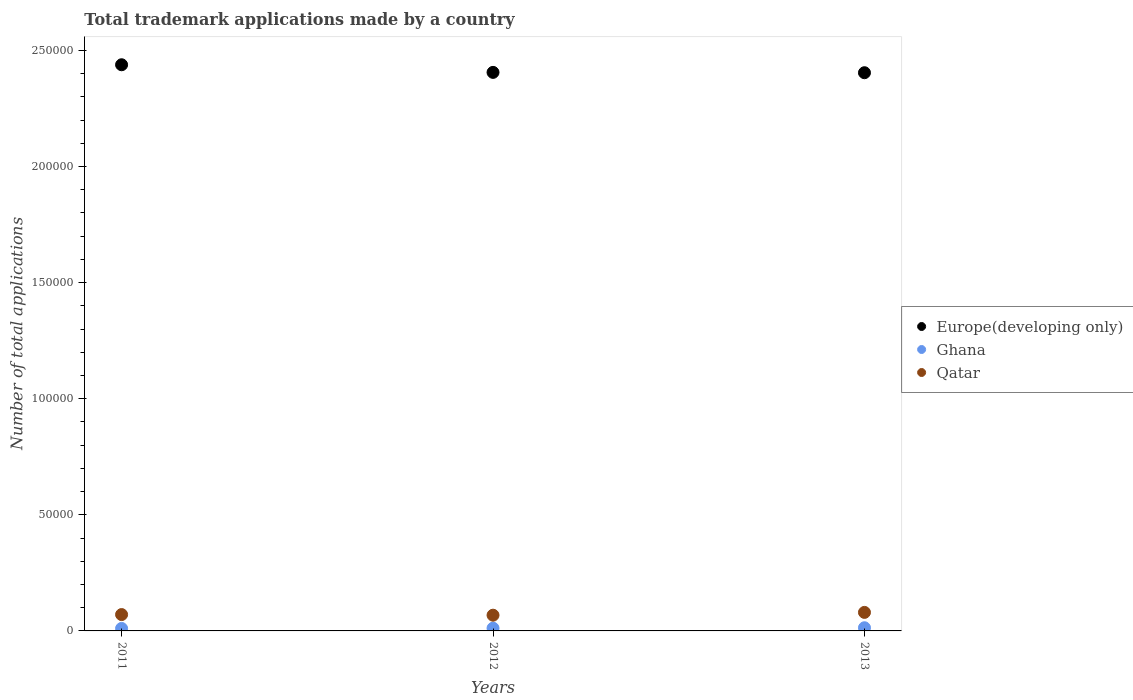How many different coloured dotlines are there?
Provide a short and direct response. 3. What is the number of applications made by in Europe(developing only) in 2011?
Your answer should be very brief. 2.44e+05. Across all years, what is the maximum number of applications made by in Europe(developing only)?
Your answer should be compact. 2.44e+05. Across all years, what is the minimum number of applications made by in Qatar?
Your answer should be very brief. 6773. In which year was the number of applications made by in Qatar maximum?
Offer a very short reply. 2013. What is the total number of applications made by in Ghana in the graph?
Offer a terse response. 3609. What is the difference between the number of applications made by in Europe(developing only) in 2011 and that in 2013?
Offer a very short reply. 3429. What is the difference between the number of applications made by in Qatar in 2011 and the number of applications made by in Europe(developing only) in 2012?
Your answer should be very brief. -2.33e+05. What is the average number of applications made by in Qatar per year?
Offer a terse response. 7265. In the year 2011, what is the difference between the number of applications made by in Qatar and number of applications made by in Europe(developing only)?
Ensure brevity in your answer.  -2.37e+05. In how many years, is the number of applications made by in Qatar greater than 120000?
Ensure brevity in your answer.  0. What is the ratio of the number of applications made by in Qatar in 2011 to that in 2012?
Your answer should be very brief. 1.04. Is the number of applications made by in Qatar in 2012 less than that in 2013?
Your answer should be very brief. Yes. What is the difference between the highest and the second highest number of applications made by in Qatar?
Your response must be concise. 936. What is the difference between the highest and the lowest number of applications made by in Ghana?
Give a very brief answer. 298. Is the sum of the number of applications made by in Qatar in 2011 and 2013 greater than the maximum number of applications made by in Europe(developing only) across all years?
Offer a terse response. No. Is the number of applications made by in Ghana strictly greater than the number of applications made by in Qatar over the years?
Give a very brief answer. No. How many dotlines are there?
Provide a short and direct response. 3. How many years are there in the graph?
Offer a very short reply. 3. What is the difference between two consecutive major ticks on the Y-axis?
Make the answer very short. 5.00e+04. Are the values on the major ticks of Y-axis written in scientific E-notation?
Ensure brevity in your answer.  No. Does the graph contain grids?
Ensure brevity in your answer.  No. Where does the legend appear in the graph?
Your answer should be very brief. Center right. How many legend labels are there?
Keep it short and to the point. 3. How are the legend labels stacked?
Give a very brief answer. Vertical. What is the title of the graph?
Keep it short and to the point. Total trademark applications made by a country. What is the label or title of the X-axis?
Give a very brief answer. Years. What is the label or title of the Y-axis?
Keep it short and to the point. Number of total applications. What is the Number of total applications in Europe(developing only) in 2011?
Your answer should be compact. 2.44e+05. What is the Number of total applications of Ghana in 2011?
Your response must be concise. 1067. What is the Number of total applications of Qatar in 2011?
Your answer should be very brief. 7043. What is the Number of total applications of Europe(developing only) in 2012?
Your response must be concise. 2.41e+05. What is the Number of total applications of Ghana in 2012?
Keep it short and to the point. 1177. What is the Number of total applications in Qatar in 2012?
Your answer should be very brief. 6773. What is the Number of total applications of Europe(developing only) in 2013?
Give a very brief answer. 2.40e+05. What is the Number of total applications in Ghana in 2013?
Offer a very short reply. 1365. What is the Number of total applications in Qatar in 2013?
Your response must be concise. 7979. Across all years, what is the maximum Number of total applications of Europe(developing only)?
Offer a very short reply. 2.44e+05. Across all years, what is the maximum Number of total applications in Ghana?
Keep it short and to the point. 1365. Across all years, what is the maximum Number of total applications of Qatar?
Provide a succinct answer. 7979. Across all years, what is the minimum Number of total applications of Europe(developing only)?
Give a very brief answer. 2.40e+05. Across all years, what is the minimum Number of total applications in Ghana?
Ensure brevity in your answer.  1067. Across all years, what is the minimum Number of total applications in Qatar?
Provide a short and direct response. 6773. What is the total Number of total applications in Europe(developing only) in the graph?
Ensure brevity in your answer.  7.25e+05. What is the total Number of total applications in Ghana in the graph?
Make the answer very short. 3609. What is the total Number of total applications in Qatar in the graph?
Your response must be concise. 2.18e+04. What is the difference between the Number of total applications of Europe(developing only) in 2011 and that in 2012?
Give a very brief answer. 3282. What is the difference between the Number of total applications of Ghana in 2011 and that in 2012?
Keep it short and to the point. -110. What is the difference between the Number of total applications in Qatar in 2011 and that in 2012?
Your answer should be compact. 270. What is the difference between the Number of total applications in Europe(developing only) in 2011 and that in 2013?
Provide a short and direct response. 3429. What is the difference between the Number of total applications in Ghana in 2011 and that in 2013?
Provide a short and direct response. -298. What is the difference between the Number of total applications of Qatar in 2011 and that in 2013?
Make the answer very short. -936. What is the difference between the Number of total applications of Europe(developing only) in 2012 and that in 2013?
Ensure brevity in your answer.  147. What is the difference between the Number of total applications of Ghana in 2012 and that in 2013?
Offer a terse response. -188. What is the difference between the Number of total applications of Qatar in 2012 and that in 2013?
Your answer should be very brief. -1206. What is the difference between the Number of total applications of Europe(developing only) in 2011 and the Number of total applications of Ghana in 2012?
Provide a short and direct response. 2.43e+05. What is the difference between the Number of total applications in Europe(developing only) in 2011 and the Number of total applications in Qatar in 2012?
Your answer should be very brief. 2.37e+05. What is the difference between the Number of total applications of Ghana in 2011 and the Number of total applications of Qatar in 2012?
Ensure brevity in your answer.  -5706. What is the difference between the Number of total applications in Europe(developing only) in 2011 and the Number of total applications in Ghana in 2013?
Your response must be concise. 2.42e+05. What is the difference between the Number of total applications in Europe(developing only) in 2011 and the Number of total applications in Qatar in 2013?
Offer a terse response. 2.36e+05. What is the difference between the Number of total applications in Ghana in 2011 and the Number of total applications in Qatar in 2013?
Your response must be concise. -6912. What is the difference between the Number of total applications of Europe(developing only) in 2012 and the Number of total applications of Ghana in 2013?
Your answer should be compact. 2.39e+05. What is the difference between the Number of total applications in Europe(developing only) in 2012 and the Number of total applications in Qatar in 2013?
Keep it short and to the point. 2.33e+05. What is the difference between the Number of total applications in Ghana in 2012 and the Number of total applications in Qatar in 2013?
Your answer should be compact. -6802. What is the average Number of total applications in Europe(developing only) per year?
Your answer should be very brief. 2.42e+05. What is the average Number of total applications of Ghana per year?
Offer a very short reply. 1203. What is the average Number of total applications of Qatar per year?
Your response must be concise. 7265. In the year 2011, what is the difference between the Number of total applications of Europe(developing only) and Number of total applications of Ghana?
Provide a succinct answer. 2.43e+05. In the year 2011, what is the difference between the Number of total applications of Europe(developing only) and Number of total applications of Qatar?
Offer a very short reply. 2.37e+05. In the year 2011, what is the difference between the Number of total applications of Ghana and Number of total applications of Qatar?
Keep it short and to the point. -5976. In the year 2012, what is the difference between the Number of total applications in Europe(developing only) and Number of total applications in Ghana?
Your response must be concise. 2.39e+05. In the year 2012, what is the difference between the Number of total applications in Europe(developing only) and Number of total applications in Qatar?
Your answer should be compact. 2.34e+05. In the year 2012, what is the difference between the Number of total applications in Ghana and Number of total applications in Qatar?
Ensure brevity in your answer.  -5596. In the year 2013, what is the difference between the Number of total applications in Europe(developing only) and Number of total applications in Ghana?
Your answer should be very brief. 2.39e+05. In the year 2013, what is the difference between the Number of total applications in Europe(developing only) and Number of total applications in Qatar?
Give a very brief answer. 2.32e+05. In the year 2013, what is the difference between the Number of total applications of Ghana and Number of total applications of Qatar?
Provide a succinct answer. -6614. What is the ratio of the Number of total applications in Europe(developing only) in 2011 to that in 2012?
Ensure brevity in your answer.  1.01. What is the ratio of the Number of total applications in Ghana in 2011 to that in 2012?
Provide a succinct answer. 0.91. What is the ratio of the Number of total applications of Qatar in 2011 to that in 2012?
Provide a succinct answer. 1.04. What is the ratio of the Number of total applications in Europe(developing only) in 2011 to that in 2013?
Provide a succinct answer. 1.01. What is the ratio of the Number of total applications in Ghana in 2011 to that in 2013?
Your answer should be compact. 0.78. What is the ratio of the Number of total applications of Qatar in 2011 to that in 2013?
Ensure brevity in your answer.  0.88. What is the ratio of the Number of total applications in Europe(developing only) in 2012 to that in 2013?
Your response must be concise. 1. What is the ratio of the Number of total applications in Ghana in 2012 to that in 2013?
Give a very brief answer. 0.86. What is the ratio of the Number of total applications of Qatar in 2012 to that in 2013?
Keep it short and to the point. 0.85. What is the difference between the highest and the second highest Number of total applications in Europe(developing only)?
Ensure brevity in your answer.  3282. What is the difference between the highest and the second highest Number of total applications of Ghana?
Offer a terse response. 188. What is the difference between the highest and the second highest Number of total applications in Qatar?
Your response must be concise. 936. What is the difference between the highest and the lowest Number of total applications in Europe(developing only)?
Offer a very short reply. 3429. What is the difference between the highest and the lowest Number of total applications of Ghana?
Your answer should be compact. 298. What is the difference between the highest and the lowest Number of total applications in Qatar?
Provide a succinct answer. 1206. 